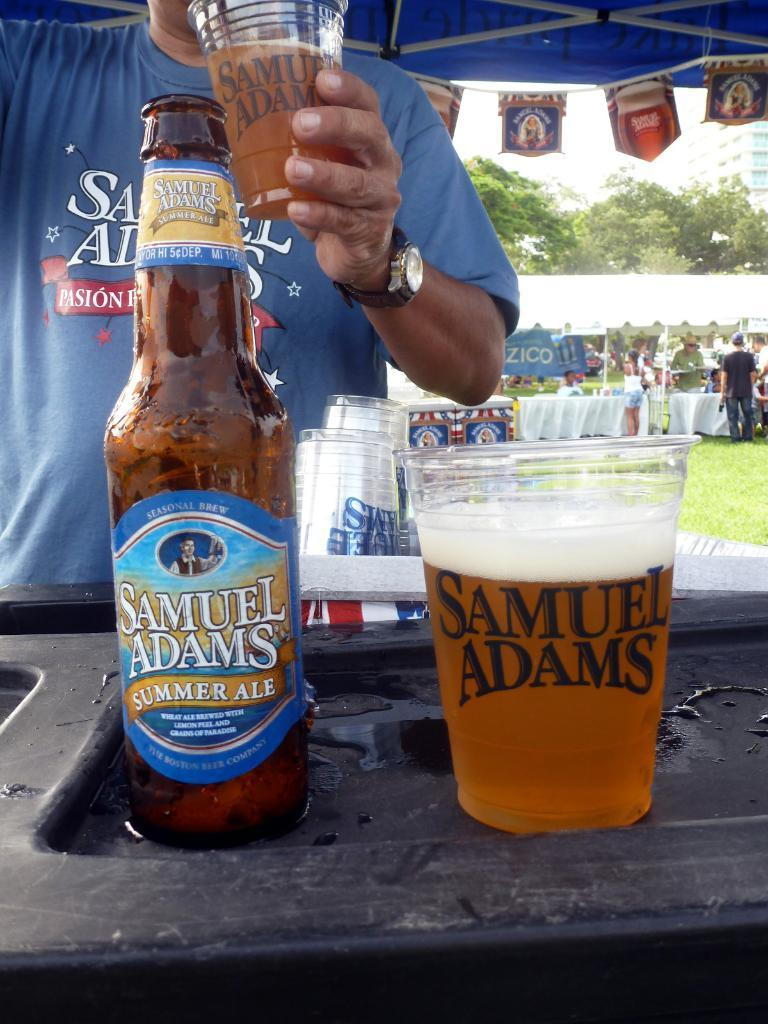<image>
Offer a succinct explanation of the picture presented. A bottle and a cup of Samuel Adams beer sitting in a beer tent at an outside event. 